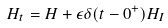<formula> <loc_0><loc_0><loc_500><loc_500>H _ { t } = H + \epsilon \delta ( t - 0 ^ { + } ) H _ { I }</formula> 